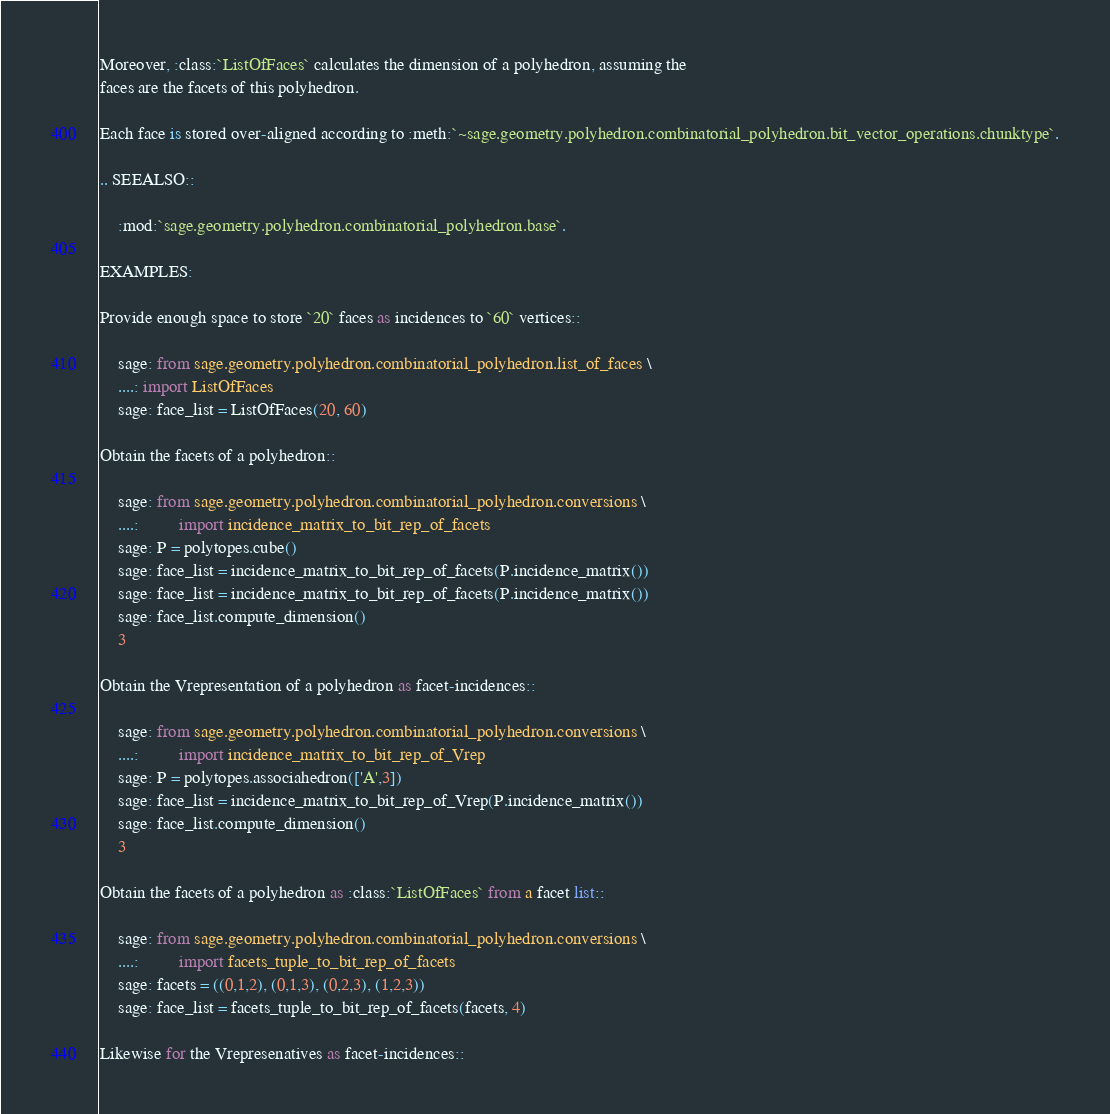Convert code to text. <code><loc_0><loc_0><loc_500><loc_500><_Cython_>
Moreover, :class:`ListOfFaces` calculates the dimension of a polyhedron, assuming the
faces are the facets of this polyhedron.

Each face is stored over-aligned according to :meth:`~sage.geometry.polyhedron.combinatorial_polyhedron.bit_vector_operations.chunktype`.

.. SEEALSO::

    :mod:`sage.geometry.polyhedron.combinatorial_polyhedron.base`.

EXAMPLES:

Provide enough space to store `20` faces as incidences to `60` vertices::

    sage: from sage.geometry.polyhedron.combinatorial_polyhedron.list_of_faces \
    ....: import ListOfFaces
    sage: face_list = ListOfFaces(20, 60)

Obtain the facets of a polyhedron::

    sage: from sage.geometry.polyhedron.combinatorial_polyhedron.conversions \
    ....:         import incidence_matrix_to_bit_rep_of_facets
    sage: P = polytopes.cube()
    sage: face_list = incidence_matrix_to_bit_rep_of_facets(P.incidence_matrix())
    sage: face_list = incidence_matrix_to_bit_rep_of_facets(P.incidence_matrix())
    sage: face_list.compute_dimension()
    3

Obtain the Vrepresentation of a polyhedron as facet-incidences::

    sage: from sage.geometry.polyhedron.combinatorial_polyhedron.conversions \
    ....:         import incidence_matrix_to_bit_rep_of_Vrep
    sage: P = polytopes.associahedron(['A',3])
    sage: face_list = incidence_matrix_to_bit_rep_of_Vrep(P.incidence_matrix())
    sage: face_list.compute_dimension()
    3

Obtain the facets of a polyhedron as :class:`ListOfFaces` from a facet list::

    sage: from sage.geometry.polyhedron.combinatorial_polyhedron.conversions \
    ....:         import facets_tuple_to_bit_rep_of_facets
    sage: facets = ((0,1,2), (0,1,3), (0,2,3), (1,2,3))
    sage: face_list = facets_tuple_to_bit_rep_of_facets(facets, 4)

Likewise for the Vrepresenatives as facet-incidences::
</code> 